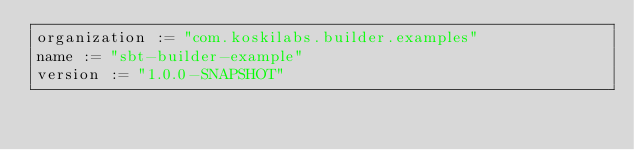<code> <loc_0><loc_0><loc_500><loc_500><_Scala_>organization := "com.koskilabs.builder.examples"
name := "sbt-builder-example"
version := "1.0.0-SNAPSHOT"
</code> 